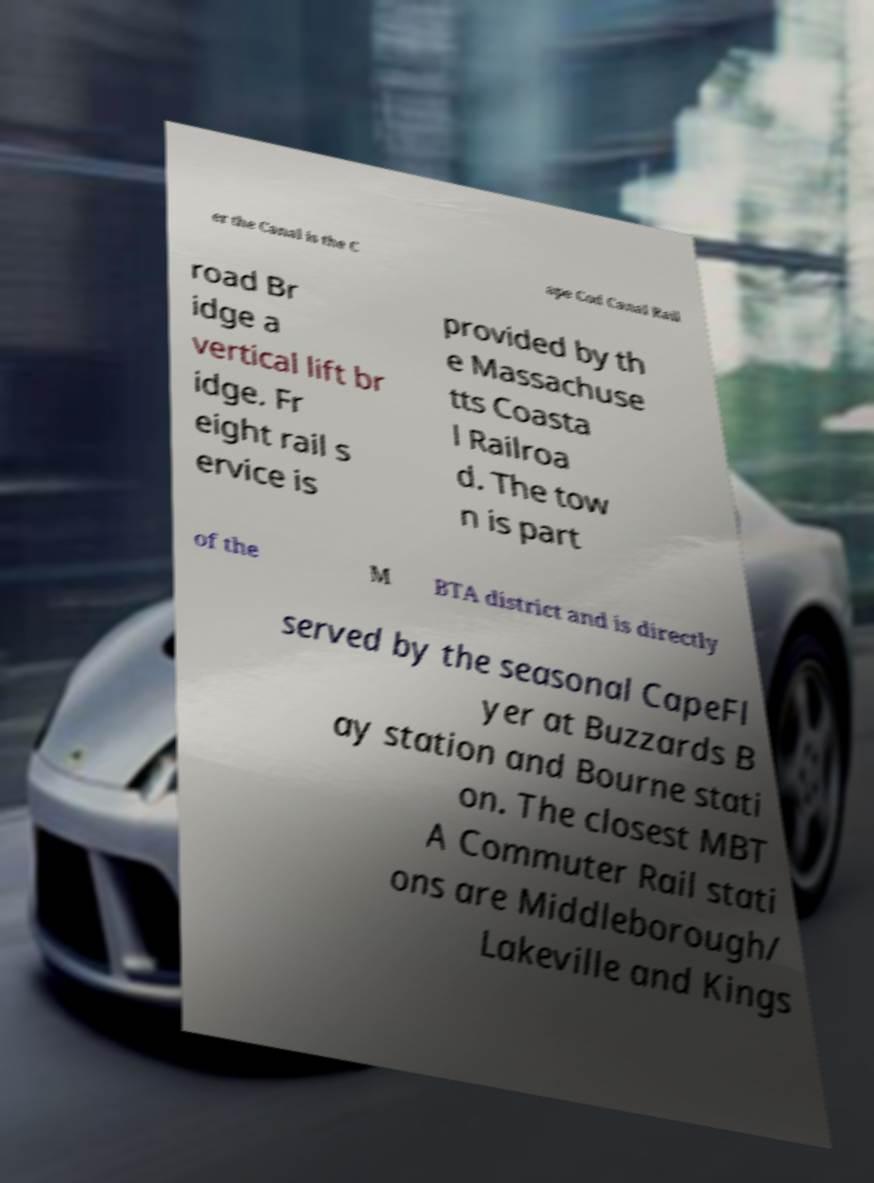Could you assist in decoding the text presented in this image and type it out clearly? er the Canal is the C ape Cod Canal Rail road Br idge a vertical lift br idge. Fr eight rail s ervice is provided by th e Massachuse tts Coasta l Railroa d. The tow n is part of the M BTA district and is directly served by the seasonal CapeFl yer at Buzzards B ay station and Bourne stati on. The closest MBT A Commuter Rail stati ons are Middleborough/ Lakeville and Kings 